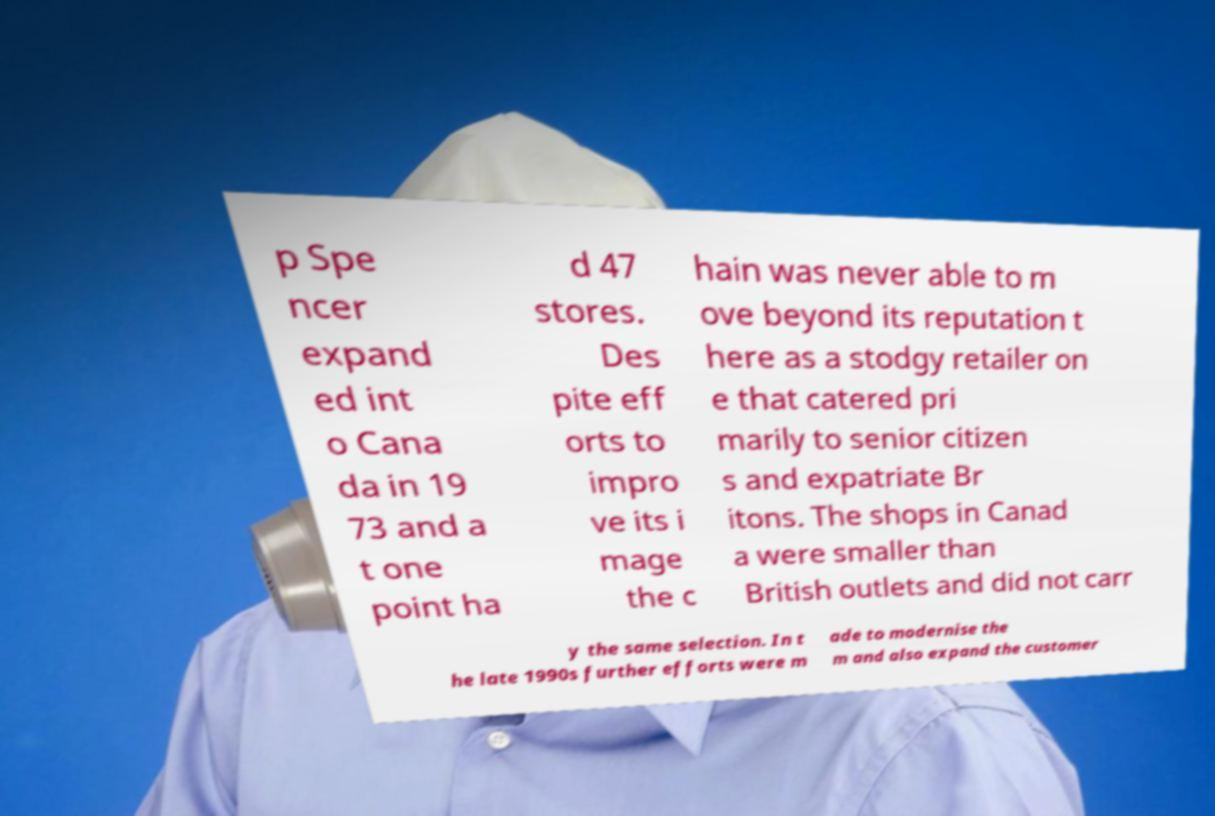Can you accurately transcribe the text from the provided image for me? p Spe ncer expand ed int o Cana da in 19 73 and a t one point ha d 47 stores. Des pite eff orts to impro ve its i mage the c hain was never able to m ove beyond its reputation t here as a stodgy retailer on e that catered pri marily to senior citizen s and expatriate Br itons. The shops in Canad a were smaller than British outlets and did not carr y the same selection. In t he late 1990s further efforts were m ade to modernise the m and also expand the customer 